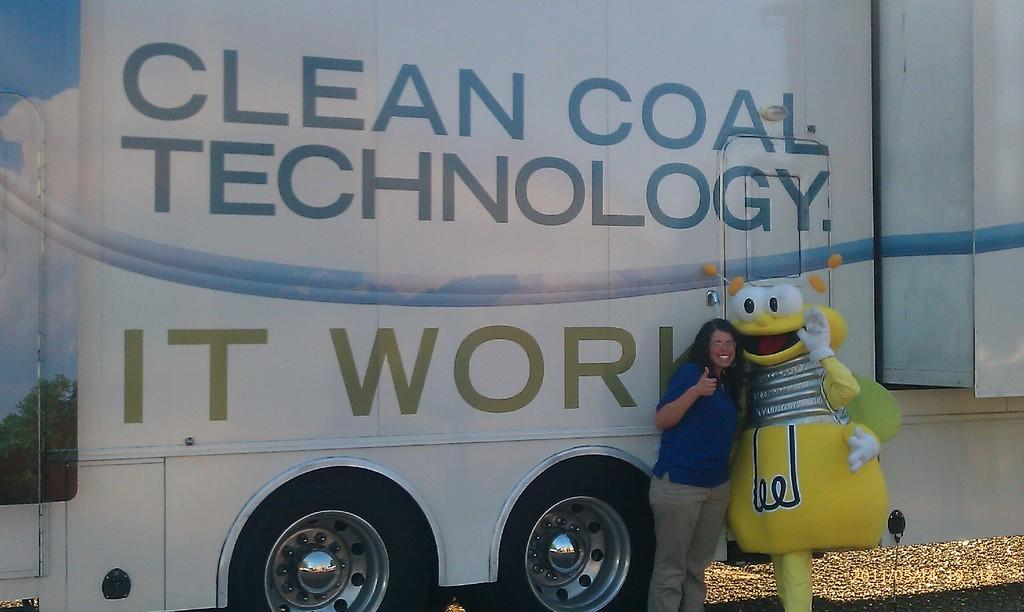What can be seen in the background of the image? There is a vehicle in the background of the image. Can you describe the woman in the image? The woman is wearing a t-shirt and spectacles in the image. What is the woman doing in the image? The woman is standing near a person wearing a fancy dress. Can you tell me how many friends are holding the cord in the image? There is no mention of a cord or friends holding it in the image. 